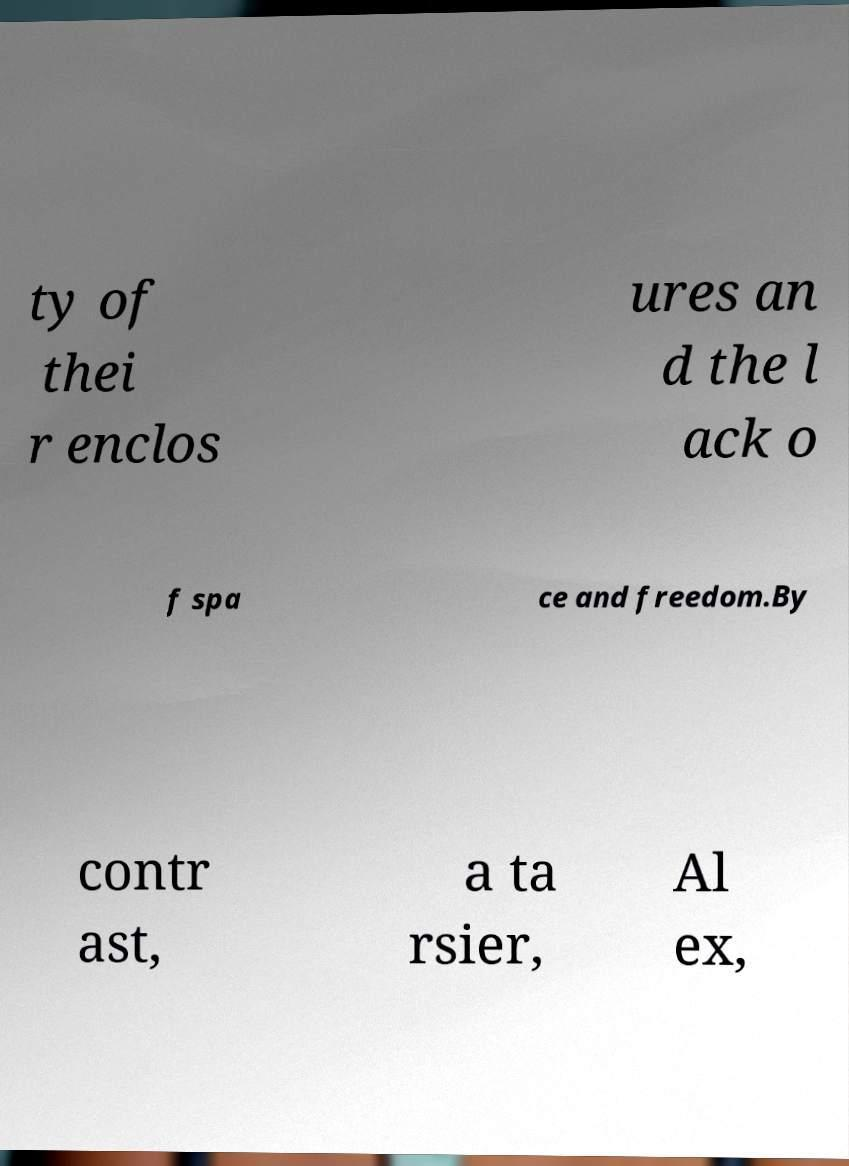Can you accurately transcribe the text from the provided image for me? ty of thei r enclos ures an d the l ack o f spa ce and freedom.By contr ast, a ta rsier, Al ex, 